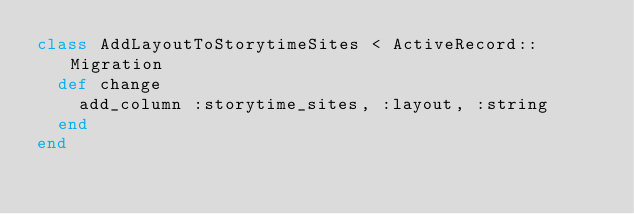Convert code to text. <code><loc_0><loc_0><loc_500><loc_500><_Ruby_>class AddLayoutToStorytimeSites < ActiveRecord::Migration
  def change
    add_column :storytime_sites, :layout, :string
  end
end
</code> 